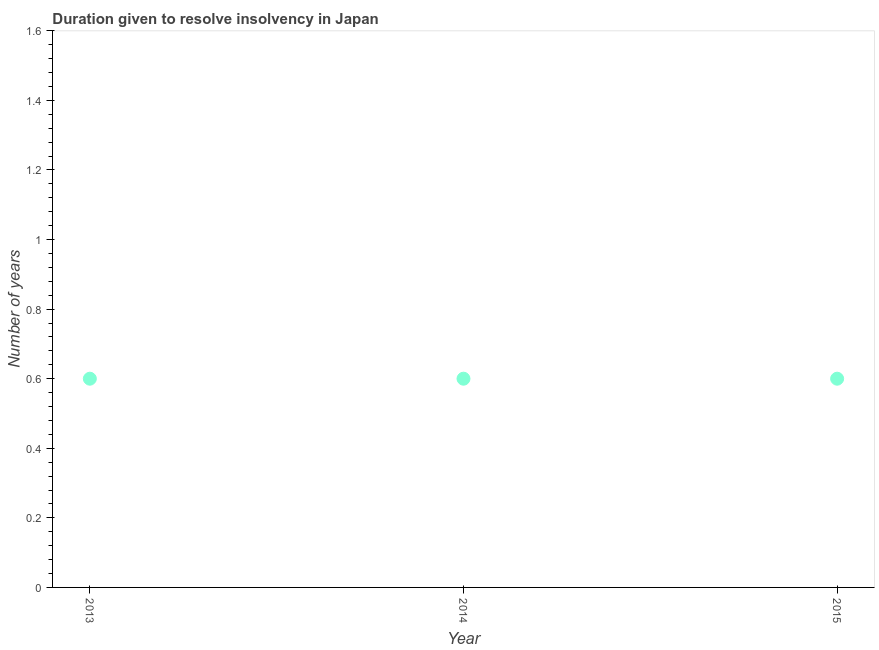Across all years, what is the maximum number of years to resolve insolvency?
Your answer should be compact. 0.6. In which year was the number of years to resolve insolvency maximum?
Give a very brief answer. 2013. What is the sum of the number of years to resolve insolvency?
Your answer should be compact. 1.8. In how many years, is the number of years to resolve insolvency greater than 0.6400000000000001 ?
Offer a terse response. 0. Do a majority of the years between 2015 and 2014 (inclusive) have number of years to resolve insolvency greater than 0.52 ?
Keep it short and to the point. No. What is the ratio of the number of years to resolve insolvency in 2013 to that in 2015?
Your answer should be compact. 1. What is the difference between the highest and the second highest number of years to resolve insolvency?
Keep it short and to the point. 0. Is the sum of the number of years to resolve insolvency in 2013 and 2015 greater than the maximum number of years to resolve insolvency across all years?
Your answer should be very brief. Yes. What is the difference between the highest and the lowest number of years to resolve insolvency?
Provide a succinct answer. 0. In how many years, is the number of years to resolve insolvency greater than the average number of years to resolve insolvency taken over all years?
Keep it short and to the point. 0. Does the number of years to resolve insolvency monotonically increase over the years?
Give a very brief answer. No. How many years are there in the graph?
Offer a very short reply. 3. Are the values on the major ticks of Y-axis written in scientific E-notation?
Your response must be concise. No. Does the graph contain grids?
Your answer should be compact. No. What is the title of the graph?
Your answer should be compact. Duration given to resolve insolvency in Japan. What is the label or title of the X-axis?
Ensure brevity in your answer.  Year. What is the label or title of the Y-axis?
Your answer should be compact. Number of years. What is the Number of years in 2013?
Provide a succinct answer. 0.6. What is the Number of years in 2014?
Provide a succinct answer. 0.6. What is the difference between the Number of years in 2013 and 2014?
Give a very brief answer. 0. What is the difference between the Number of years in 2014 and 2015?
Your response must be concise. 0. What is the ratio of the Number of years in 2013 to that in 2015?
Make the answer very short. 1. 